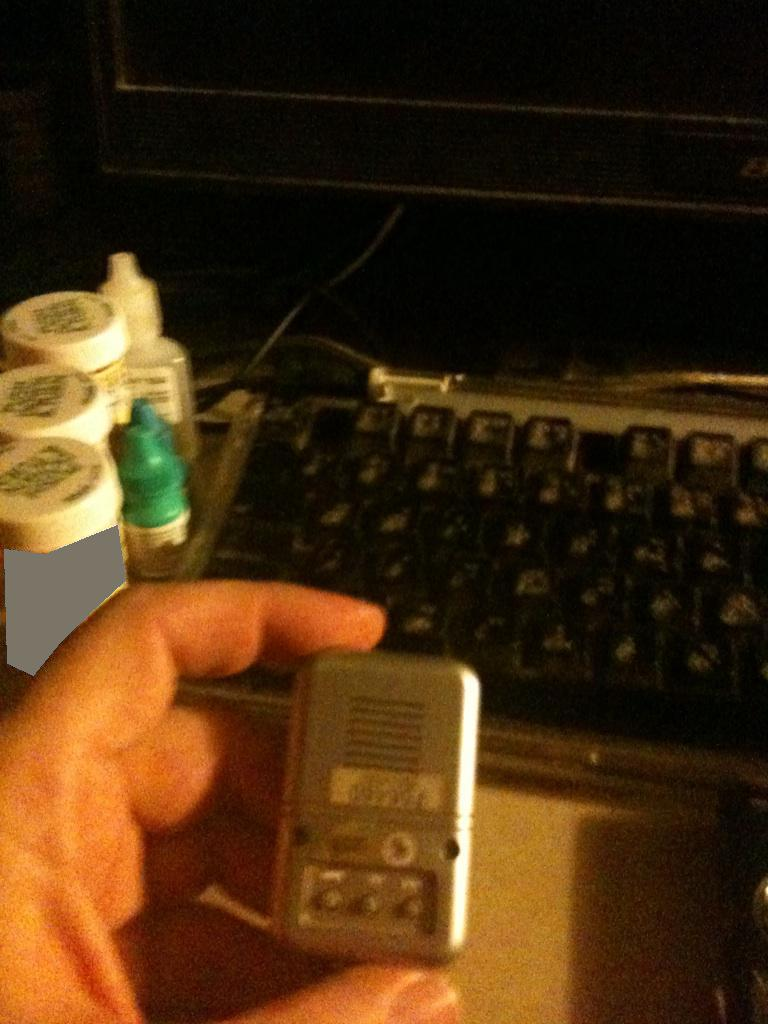What items can you identify in this setup? The image features a keyboard, several small containers that appear to be eye drop bottles or similar, and a small electronic device being held in a hand. There is also part of a monitor or a screen visible in the background. What could these items be used for? The keyboard is likely used for typing and interacting with a computer. The small containers might be used for storing medications or solutions, possibly for eye care given their appearance. The electronic device held in the hand could be something related to computing or another type of gadget, but its specific function isn't clear from the image alone. 